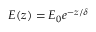<formula> <loc_0><loc_0><loc_500><loc_500>E ( z ) = E _ { 0 } e ^ { - z / \delta }</formula> 